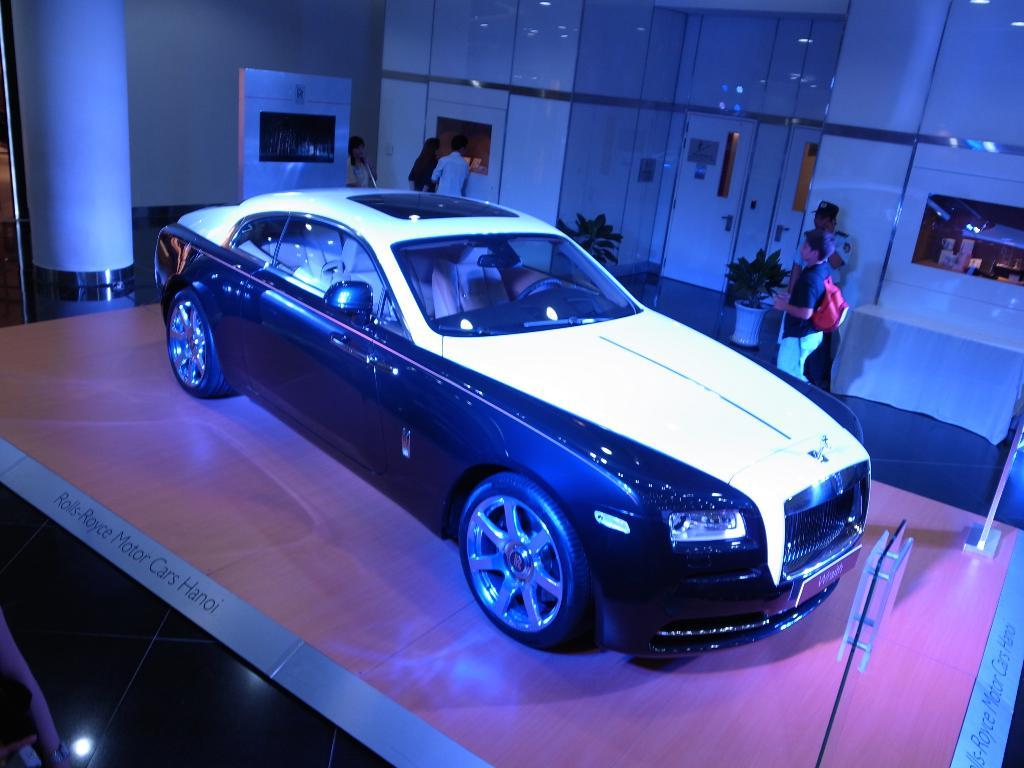What type of structure can be seen in the image? There is a wall in the image. What feature is typically used for entering or exiting a building? There is a door in the image. What type of vegetation is present in the image? There are plants in the image. What are the pots used for in the image? The pots are likely used for holding the plants. Who or what is present in the image? There are people and a car in the image. What language is being spoken by the wall in the image? Walls do not speak languages, so this question is not applicable to the image. 